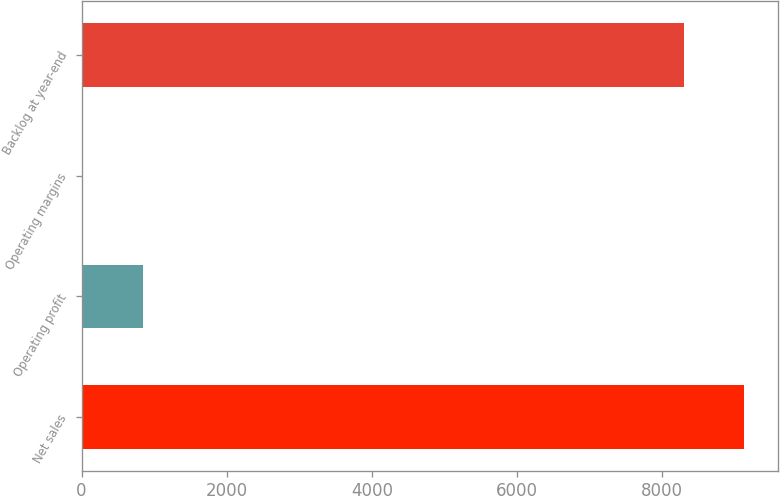<chart> <loc_0><loc_0><loc_500><loc_500><bar_chart><fcel>Net sales<fcel>Operating profit<fcel>Operating margins<fcel>Backlog at year-end<nl><fcel>9135.79<fcel>844.89<fcel>9.1<fcel>8300<nl></chart> 